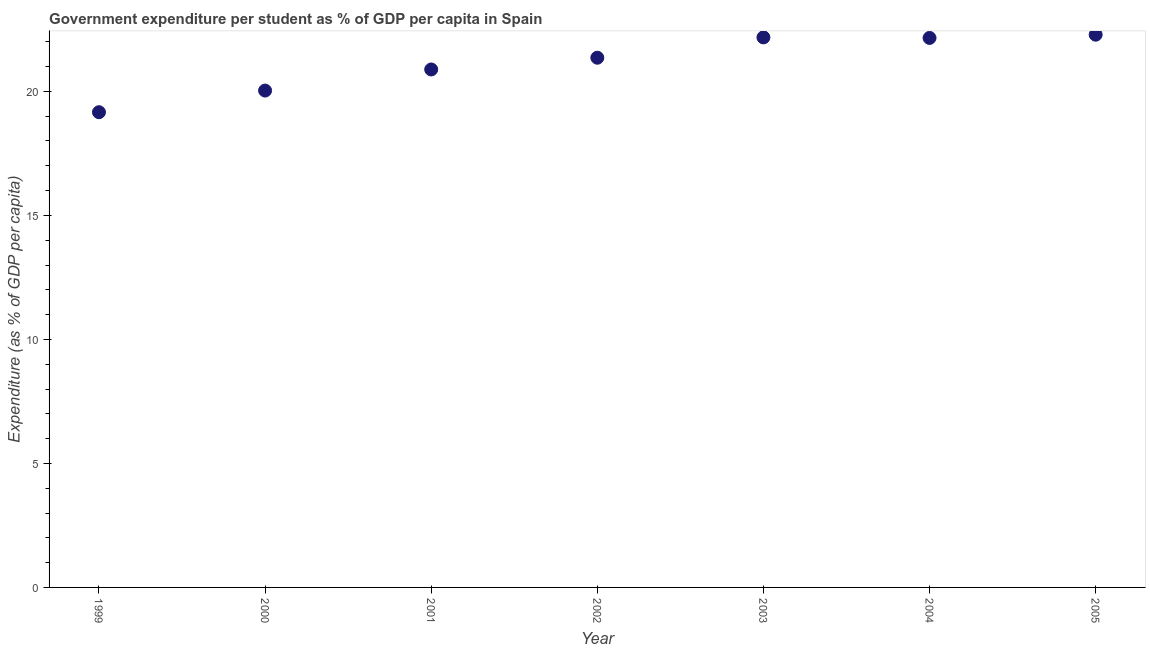What is the government expenditure per student in 2002?
Ensure brevity in your answer.  21.36. Across all years, what is the maximum government expenditure per student?
Give a very brief answer. 22.29. Across all years, what is the minimum government expenditure per student?
Your answer should be very brief. 19.16. In which year was the government expenditure per student maximum?
Ensure brevity in your answer.  2005. In which year was the government expenditure per student minimum?
Offer a terse response. 1999. What is the sum of the government expenditure per student?
Offer a terse response. 148.05. What is the difference between the government expenditure per student in 1999 and 2003?
Make the answer very short. -3.02. What is the average government expenditure per student per year?
Give a very brief answer. 21.15. What is the median government expenditure per student?
Provide a short and direct response. 21.36. What is the ratio of the government expenditure per student in 2003 to that in 2004?
Keep it short and to the point. 1. Is the difference between the government expenditure per student in 2001 and 2004 greater than the difference between any two years?
Offer a very short reply. No. What is the difference between the highest and the second highest government expenditure per student?
Provide a short and direct response. 0.11. Is the sum of the government expenditure per student in 2001 and 2005 greater than the maximum government expenditure per student across all years?
Your answer should be compact. Yes. What is the difference between the highest and the lowest government expenditure per student?
Offer a terse response. 3.12. How many years are there in the graph?
Your answer should be compact. 7. What is the difference between two consecutive major ticks on the Y-axis?
Offer a terse response. 5. Are the values on the major ticks of Y-axis written in scientific E-notation?
Provide a short and direct response. No. Does the graph contain any zero values?
Provide a short and direct response. No. Does the graph contain grids?
Your answer should be compact. No. What is the title of the graph?
Provide a succinct answer. Government expenditure per student as % of GDP per capita in Spain. What is the label or title of the X-axis?
Your answer should be very brief. Year. What is the label or title of the Y-axis?
Give a very brief answer. Expenditure (as % of GDP per capita). What is the Expenditure (as % of GDP per capita) in 1999?
Keep it short and to the point. 19.16. What is the Expenditure (as % of GDP per capita) in 2000?
Offer a terse response. 20.03. What is the Expenditure (as % of GDP per capita) in 2001?
Your answer should be compact. 20.88. What is the Expenditure (as % of GDP per capita) in 2002?
Provide a succinct answer. 21.36. What is the Expenditure (as % of GDP per capita) in 2003?
Offer a very short reply. 22.18. What is the Expenditure (as % of GDP per capita) in 2004?
Provide a succinct answer. 22.16. What is the Expenditure (as % of GDP per capita) in 2005?
Provide a short and direct response. 22.29. What is the difference between the Expenditure (as % of GDP per capita) in 1999 and 2000?
Offer a very short reply. -0.87. What is the difference between the Expenditure (as % of GDP per capita) in 1999 and 2001?
Ensure brevity in your answer.  -1.72. What is the difference between the Expenditure (as % of GDP per capita) in 1999 and 2002?
Offer a terse response. -2.2. What is the difference between the Expenditure (as % of GDP per capita) in 1999 and 2003?
Give a very brief answer. -3.02. What is the difference between the Expenditure (as % of GDP per capita) in 1999 and 2004?
Give a very brief answer. -2.99. What is the difference between the Expenditure (as % of GDP per capita) in 1999 and 2005?
Keep it short and to the point. -3.12. What is the difference between the Expenditure (as % of GDP per capita) in 2000 and 2001?
Offer a very short reply. -0.85. What is the difference between the Expenditure (as % of GDP per capita) in 2000 and 2002?
Provide a succinct answer. -1.32. What is the difference between the Expenditure (as % of GDP per capita) in 2000 and 2003?
Offer a very short reply. -2.14. What is the difference between the Expenditure (as % of GDP per capita) in 2000 and 2004?
Offer a terse response. -2.12. What is the difference between the Expenditure (as % of GDP per capita) in 2000 and 2005?
Ensure brevity in your answer.  -2.25. What is the difference between the Expenditure (as % of GDP per capita) in 2001 and 2002?
Offer a terse response. -0.47. What is the difference between the Expenditure (as % of GDP per capita) in 2001 and 2003?
Ensure brevity in your answer.  -1.29. What is the difference between the Expenditure (as % of GDP per capita) in 2001 and 2004?
Make the answer very short. -1.27. What is the difference between the Expenditure (as % of GDP per capita) in 2001 and 2005?
Provide a succinct answer. -1.4. What is the difference between the Expenditure (as % of GDP per capita) in 2002 and 2003?
Your answer should be very brief. -0.82. What is the difference between the Expenditure (as % of GDP per capita) in 2002 and 2004?
Offer a very short reply. -0.8. What is the difference between the Expenditure (as % of GDP per capita) in 2002 and 2005?
Offer a very short reply. -0.93. What is the difference between the Expenditure (as % of GDP per capita) in 2003 and 2004?
Offer a terse response. 0.02. What is the difference between the Expenditure (as % of GDP per capita) in 2003 and 2005?
Ensure brevity in your answer.  -0.11. What is the difference between the Expenditure (as % of GDP per capita) in 2004 and 2005?
Make the answer very short. -0.13. What is the ratio of the Expenditure (as % of GDP per capita) in 1999 to that in 2000?
Offer a terse response. 0.96. What is the ratio of the Expenditure (as % of GDP per capita) in 1999 to that in 2001?
Your answer should be compact. 0.92. What is the ratio of the Expenditure (as % of GDP per capita) in 1999 to that in 2002?
Offer a terse response. 0.9. What is the ratio of the Expenditure (as % of GDP per capita) in 1999 to that in 2003?
Offer a very short reply. 0.86. What is the ratio of the Expenditure (as % of GDP per capita) in 1999 to that in 2004?
Offer a terse response. 0.86. What is the ratio of the Expenditure (as % of GDP per capita) in 1999 to that in 2005?
Your response must be concise. 0.86. What is the ratio of the Expenditure (as % of GDP per capita) in 2000 to that in 2002?
Your answer should be very brief. 0.94. What is the ratio of the Expenditure (as % of GDP per capita) in 2000 to that in 2003?
Offer a very short reply. 0.9. What is the ratio of the Expenditure (as % of GDP per capita) in 2000 to that in 2004?
Your answer should be very brief. 0.9. What is the ratio of the Expenditure (as % of GDP per capita) in 2000 to that in 2005?
Ensure brevity in your answer.  0.9. What is the ratio of the Expenditure (as % of GDP per capita) in 2001 to that in 2003?
Ensure brevity in your answer.  0.94. What is the ratio of the Expenditure (as % of GDP per capita) in 2001 to that in 2004?
Offer a very short reply. 0.94. What is the ratio of the Expenditure (as % of GDP per capita) in 2001 to that in 2005?
Ensure brevity in your answer.  0.94. What is the ratio of the Expenditure (as % of GDP per capita) in 2002 to that in 2003?
Provide a short and direct response. 0.96. What is the ratio of the Expenditure (as % of GDP per capita) in 2002 to that in 2005?
Your answer should be very brief. 0.96. What is the ratio of the Expenditure (as % of GDP per capita) in 2003 to that in 2004?
Provide a short and direct response. 1. 